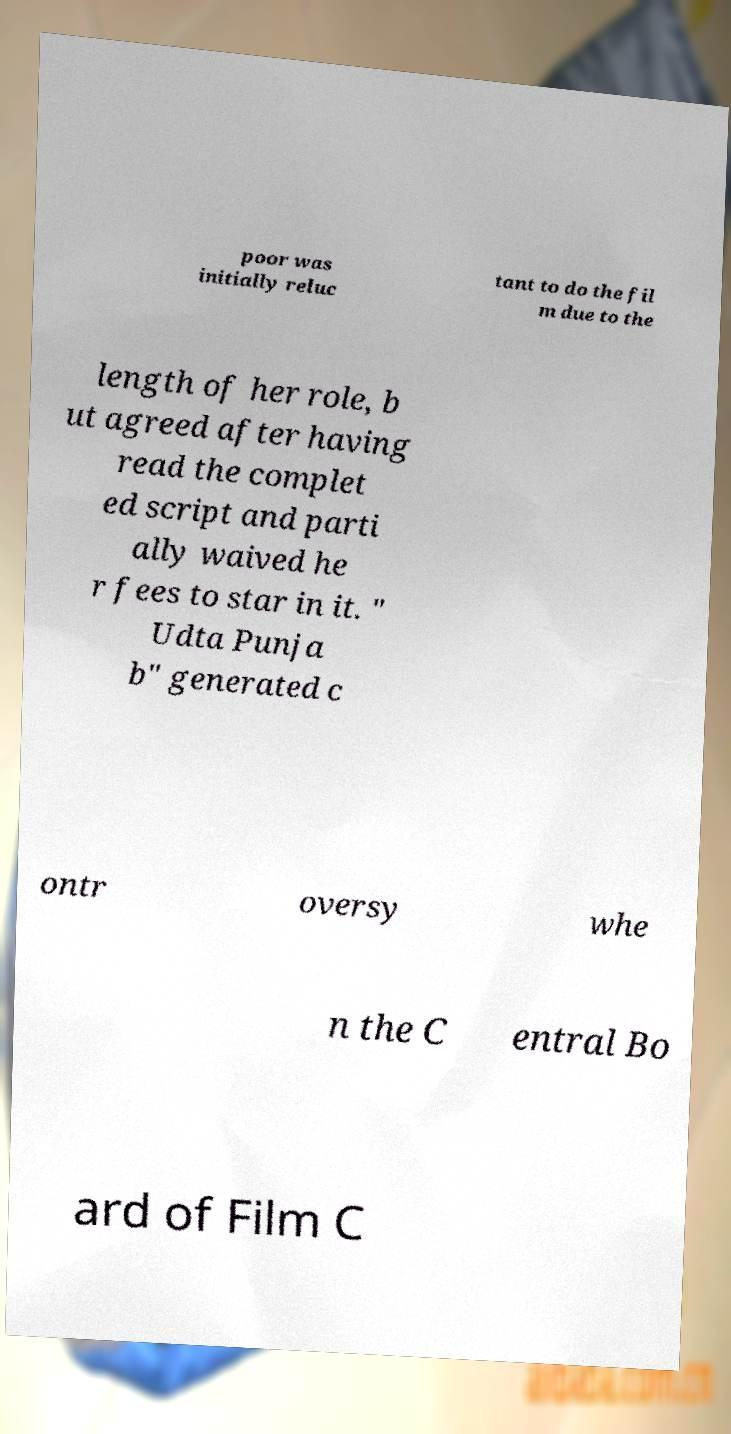Please identify and transcribe the text found in this image. poor was initially reluc tant to do the fil m due to the length of her role, b ut agreed after having read the complet ed script and parti ally waived he r fees to star in it. " Udta Punja b" generated c ontr oversy whe n the C entral Bo ard of Film C 